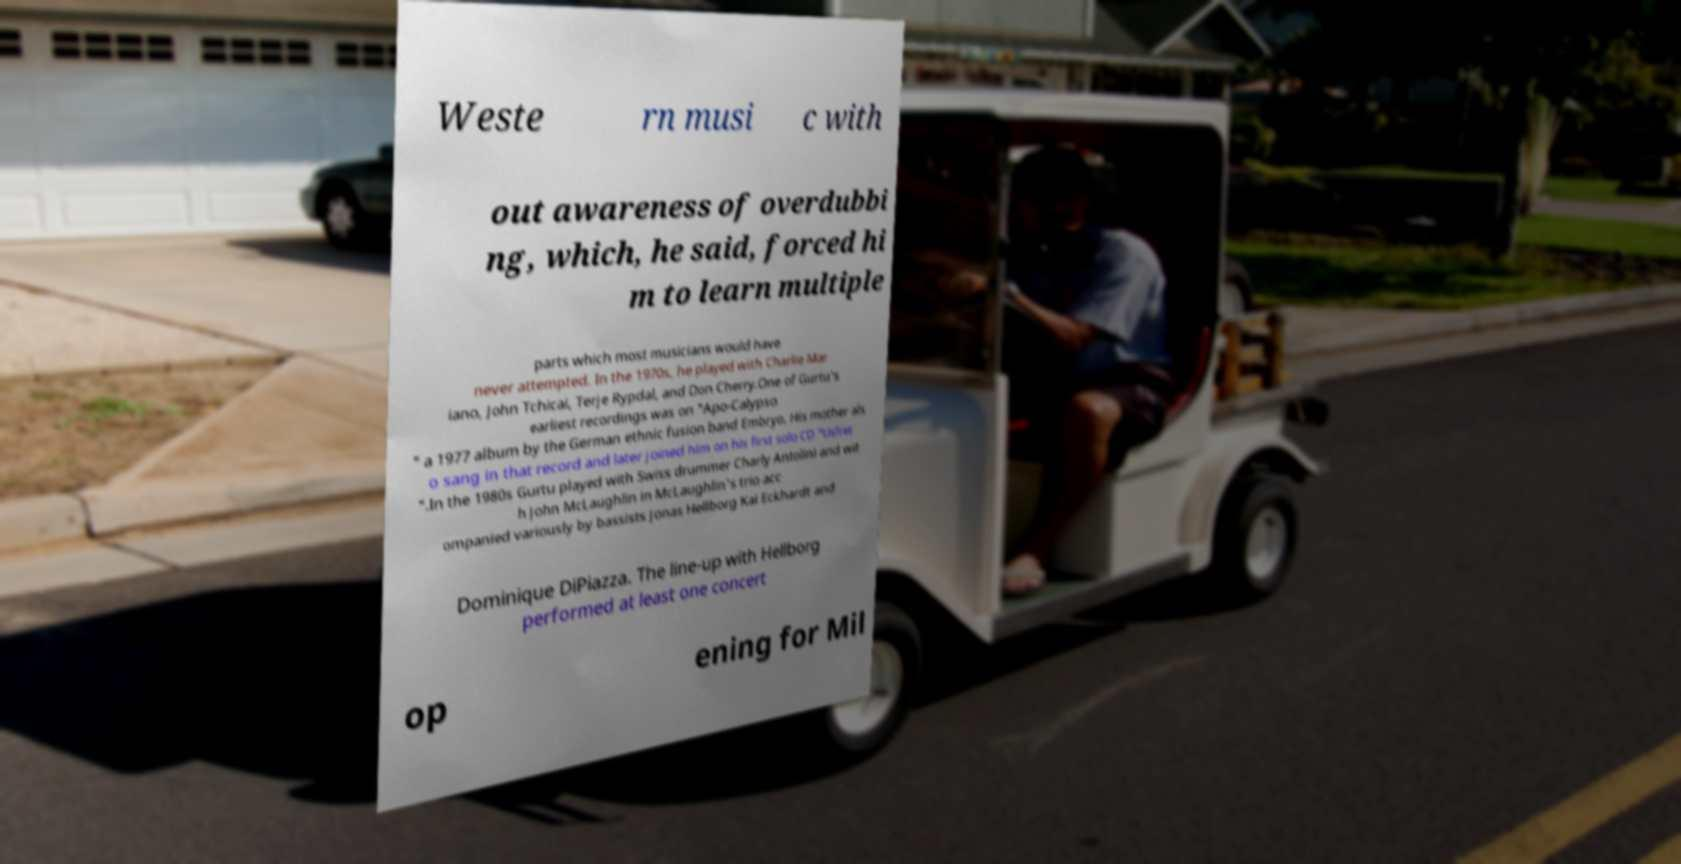Can you accurately transcribe the text from the provided image for me? Weste rn musi c with out awareness of overdubbi ng, which, he said, forced hi m to learn multiple parts which most musicians would have never attempted. In the 1970s, he played with Charlie Mar iano, John Tchicai, Terje Rypdal, and Don Cherry.One of Gurtu's earliest recordings was on "Apo-Calypso " a 1977 album by the German ethnic fusion band Embryo. His mother als o sang in that record and later joined him on his first solo CD "Usfret ".In the 1980s Gurtu played with Swiss drummer Charly Antolini and wit h John McLaughlin in McLaughlin's trio acc ompanied variously by bassists Jonas Hellborg Kai Eckhardt and Dominique DiPiazza. The line-up with Hellborg performed at least one concert op ening for Mil 